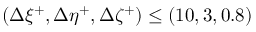<formula> <loc_0><loc_0><loc_500><loc_500>( \Delta \xi ^ { + } , \Delta \eta ^ { + } , \Delta \zeta ^ { + } ) \leq ( 1 0 , 3 , 0 . 8 )</formula> 